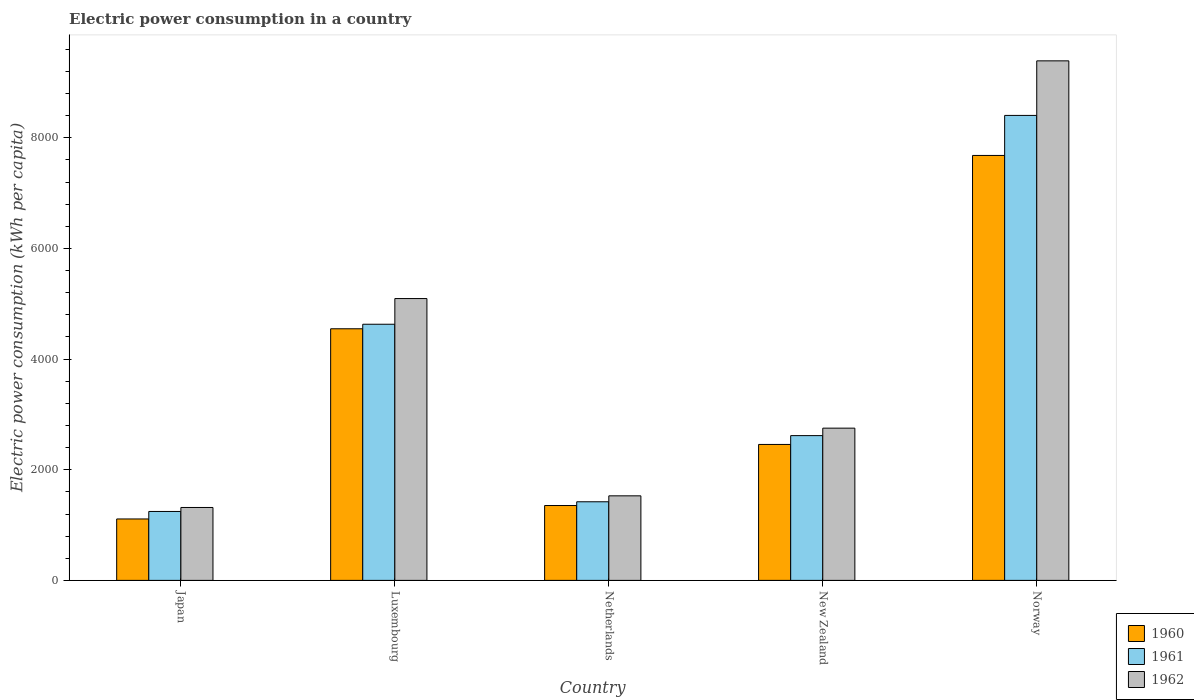How many different coloured bars are there?
Provide a short and direct response. 3. How many groups of bars are there?
Your answer should be compact. 5. Are the number of bars on each tick of the X-axis equal?
Make the answer very short. Yes. What is the label of the 1st group of bars from the left?
Keep it short and to the point. Japan. What is the electric power consumption in in 1961 in Japan?
Make the answer very short. 1246.01. Across all countries, what is the maximum electric power consumption in in 1962?
Keep it short and to the point. 9390.98. Across all countries, what is the minimum electric power consumption in in 1960?
Provide a succinct answer. 1110.26. In which country was the electric power consumption in in 1962 maximum?
Your response must be concise. Norway. What is the total electric power consumption in in 1960 in the graph?
Your answer should be compact. 1.72e+04. What is the difference between the electric power consumption in in 1961 in Japan and that in Luxembourg?
Make the answer very short. -3384.01. What is the difference between the electric power consumption in in 1961 in New Zealand and the electric power consumption in in 1962 in Norway?
Ensure brevity in your answer.  -6774.12. What is the average electric power consumption in in 1960 per country?
Give a very brief answer. 3430.04. What is the difference between the electric power consumption in of/in 1961 and electric power consumption in of/in 1962 in Luxembourg?
Keep it short and to the point. -464.29. In how many countries, is the electric power consumption in in 1962 greater than 800 kWh per capita?
Keep it short and to the point. 5. What is the ratio of the electric power consumption in in 1962 in Japan to that in Netherlands?
Your answer should be very brief. 0.86. Is the electric power consumption in in 1961 in Netherlands less than that in Norway?
Offer a very short reply. Yes. Is the difference between the electric power consumption in in 1961 in Luxembourg and Netherlands greater than the difference between the electric power consumption in in 1962 in Luxembourg and Netherlands?
Your response must be concise. No. What is the difference between the highest and the second highest electric power consumption in in 1962?
Ensure brevity in your answer.  -4296.67. What is the difference between the highest and the lowest electric power consumption in in 1962?
Give a very brief answer. 8073.05. Is the sum of the electric power consumption in in 1962 in Netherlands and Norway greater than the maximum electric power consumption in in 1960 across all countries?
Provide a short and direct response. Yes. What does the 1st bar from the left in Luxembourg represents?
Your response must be concise. 1960. What does the 2nd bar from the right in Netherlands represents?
Your answer should be compact. 1961. Is it the case that in every country, the sum of the electric power consumption in in 1962 and electric power consumption in in 1961 is greater than the electric power consumption in in 1960?
Your response must be concise. Yes. Does the graph contain any zero values?
Your response must be concise. No. Does the graph contain grids?
Offer a terse response. No. Where does the legend appear in the graph?
Your answer should be compact. Bottom right. How many legend labels are there?
Offer a terse response. 3. What is the title of the graph?
Your response must be concise. Electric power consumption in a country. Does "1991" appear as one of the legend labels in the graph?
Offer a terse response. No. What is the label or title of the Y-axis?
Provide a succinct answer. Electric power consumption (kWh per capita). What is the Electric power consumption (kWh per capita) of 1960 in Japan?
Your answer should be very brief. 1110.26. What is the Electric power consumption (kWh per capita) of 1961 in Japan?
Give a very brief answer. 1246.01. What is the Electric power consumption (kWh per capita) of 1962 in Japan?
Your answer should be compact. 1317.93. What is the Electric power consumption (kWh per capita) of 1960 in Luxembourg?
Provide a short and direct response. 4548.21. What is the Electric power consumption (kWh per capita) of 1961 in Luxembourg?
Offer a terse response. 4630.02. What is the Electric power consumption (kWh per capita) in 1962 in Luxembourg?
Offer a terse response. 5094.31. What is the Electric power consumption (kWh per capita) of 1960 in Netherlands?
Ensure brevity in your answer.  1353.4. What is the Electric power consumption (kWh per capita) in 1961 in Netherlands?
Provide a short and direct response. 1421.03. What is the Electric power consumption (kWh per capita) in 1962 in Netherlands?
Provide a short and direct response. 1528.5. What is the Electric power consumption (kWh per capita) of 1960 in New Zealand?
Your response must be concise. 2457.21. What is the Electric power consumption (kWh per capita) in 1961 in New Zealand?
Offer a very short reply. 2616.85. What is the Electric power consumption (kWh per capita) in 1962 in New Zealand?
Keep it short and to the point. 2751.81. What is the Electric power consumption (kWh per capita) in 1960 in Norway?
Keep it short and to the point. 7681.14. What is the Electric power consumption (kWh per capita) in 1961 in Norway?
Your response must be concise. 8404.62. What is the Electric power consumption (kWh per capita) in 1962 in Norway?
Provide a short and direct response. 9390.98. Across all countries, what is the maximum Electric power consumption (kWh per capita) in 1960?
Give a very brief answer. 7681.14. Across all countries, what is the maximum Electric power consumption (kWh per capita) in 1961?
Keep it short and to the point. 8404.62. Across all countries, what is the maximum Electric power consumption (kWh per capita) in 1962?
Provide a short and direct response. 9390.98. Across all countries, what is the minimum Electric power consumption (kWh per capita) in 1960?
Provide a succinct answer. 1110.26. Across all countries, what is the minimum Electric power consumption (kWh per capita) in 1961?
Give a very brief answer. 1246.01. Across all countries, what is the minimum Electric power consumption (kWh per capita) of 1962?
Offer a very short reply. 1317.93. What is the total Electric power consumption (kWh per capita) of 1960 in the graph?
Ensure brevity in your answer.  1.72e+04. What is the total Electric power consumption (kWh per capita) of 1961 in the graph?
Ensure brevity in your answer.  1.83e+04. What is the total Electric power consumption (kWh per capita) of 1962 in the graph?
Provide a succinct answer. 2.01e+04. What is the difference between the Electric power consumption (kWh per capita) of 1960 in Japan and that in Luxembourg?
Keep it short and to the point. -3437.94. What is the difference between the Electric power consumption (kWh per capita) in 1961 in Japan and that in Luxembourg?
Provide a short and direct response. -3384.01. What is the difference between the Electric power consumption (kWh per capita) of 1962 in Japan and that in Luxembourg?
Ensure brevity in your answer.  -3776.38. What is the difference between the Electric power consumption (kWh per capita) of 1960 in Japan and that in Netherlands?
Give a very brief answer. -243.14. What is the difference between the Electric power consumption (kWh per capita) in 1961 in Japan and that in Netherlands?
Your answer should be very brief. -175.02. What is the difference between the Electric power consumption (kWh per capita) of 1962 in Japan and that in Netherlands?
Make the answer very short. -210.57. What is the difference between the Electric power consumption (kWh per capita) of 1960 in Japan and that in New Zealand?
Your answer should be compact. -1346.94. What is the difference between the Electric power consumption (kWh per capita) in 1961 in Japan and that in New Zealand?
Keep it short and to the point. -1370.84. What is the difference between the Electric power consumption (kWh per capita) of 1962 in Japan and that in New Zealand?
Your response must be concise. -1433.88. What is the difference between the Electric power consumption (kWh per capita) in 1960 in Japan and that in Norway?
Provide a succinct answer. -6570.88. What is the difference between the Electric power consumption (kWh per capita) in 1961 in Japan and that in Norway?
Your response must be concise. -7158.61. What is the difference between the Electric power consumption (kWh per capita) in 1962 in Japan and that in Norway?
Your answer should be very brief. -8073.05. What is the difference between the Electric power consumption (kWh per capita) of 1960 in Luxembourg and that in Netherlands?
Provide a succinct answer. 3194.81. What is the difference between the Electric power consumption (kWh per capita) of 1961 in Luxembourg and that in Netherlands?
Provide a short and direct response. 3208.99. What is the difference between the Electric power consumption (kWh per capita) of 1962 in Luxembourg and that in Netherlands?
Offer a very short reply. 3565.81. What is the difference between the Electric power consumption (kWh per capita) of 1960 in Luxembourg and that in New Zealand?
Offer a terse response. 2091. What is the difference between the Electric power consumption (kWh per capita) of 1961 in Luxembourg and that in New Zealand?
Keep it short and to the point. 2013.17. What is the difference between the Electric power consumption (kWh per capita) in 1962 in Luxembourg and that in New Zealand?
Provide a short and direct response. 2342.5. What is the difference between the Electric power consumption (kWh per capita) in 1960 in Luxembourg and that in Norway?
Offer a terse response. -3132.94. What is the difference between the Electric power consumption (kWh per capita) in 1961 in Luxembourg and that in Norway?
Ensure brevity in your answer.  -3774.6. What is the difference between the Electric power consumption (kWh per capita) of 1962 in Luxembourg and that in Norway?
Make the answer very short. -4296.67. What is the difference between the Electric power consumption (kWh per capita) of 1960 in Netherlands and that in New Zealand?
Your response must be concise. -1103.81. What is the difference between the Electric power consumption (kWh per capita) in 1961 in Netherlands and that in New Zealand?
Offer a terse response. -1195.82. What is the difference between the Electric power consumption (kWh per capita) of 1962 in Netherlands and that in New Zealand?
Ensure brevity in your answer.  -1223.31. What is the difference between the Electric power consumption (kWh per capita) of 1960 in Netherlands and that in Norway?
Provide a succinct answer. -6327.74. What is the difference between the Electric power consumption (kWh per capita) of 1961 in Netherlands and that in Norway?
Offer a terse response. -6983.59. What is the difference between the Electric power consumption (kWh per capita) of 1962 in Netherlands and that in Norway?
Offer a terse response. -7862.48. What is the difference between the Electric power consumption (kWh per capita) of 1960 in New Zealand and that in Norway?
Your answer should be compact. -5223.94. What is the difference between the Electric power consumption (kWh per capita) of 1961 in New Zealand and that in Norway?
Keep it short and to the point. -5787.77. What is the difference between the Electric power consumption (kWh per capita) in 1962 in New Zealand and that in Norway?
Your answer should be compact. -6639.17. What is the difference between the Electric power consumption (kWh per capita) in 1960 in Japan and the Electric power consumption (kWh per capita) in 1961 in Luxembourg?
Your answer should be compact. -3519.76. What is the difference between the Electric power consumption (kWh per capita) in 1960 in Japan and the Electric power consumption (kWh per capita) in 1962 in Luxembourg?
Offer a terse response. -3984.05. What is the difference between the Electric power consumption (kWh per capita) of 1961 in Japan and the Electric power consumption (kWh per capita) of 1962 in Luxembourg?
Keep it short and to the point. -3848.3. What is the difference between the Electric power consumption (kWh per capita) of 1960 in Japan and the Electric power consumption (kWh per capita) of 1961 in Netherlands?
Provide a succinct answer. -310.77. What is the difference between the Electric power consumption (kWh per capita) in 1960 in Japan and the Electric power consumption (kWh per capita) in 1962 in Netherlands?
Your response must be concise. -418.24. What is the difference between the Electric power consumption (kWh per capita) in 1961 in Japan and the Electric power consumption (kWh per capita) in 1962 in Netherlands?
Your answer should be very brief. -282.49. What is the difference between the Electric power consumption (kWh per capita) of 1960 in Japan and the Electric power consumption (kWh per capita) of 1961 in New Zealand?
Your response must be concise. -1506.59. What is the difference between the Electric power consumption (kWh per capita) of 1960 in Japan and the Electric power consumption (kWh per capita) of 1962 in New Zealand?
Ensure brevity in your answer.  -1641.55. What is the difference between the Electric power consumption (kWh per capita) of 1961 in Japan and the Electric power consumption (kWh per capita) of 1962 in New Zealand?
Give a very brief answer. -1505.8. What is the difference between the Electric power consumption (kWh per capita) in 1960 in Japan and the Electric power consumption (kWh per capita) in 1961 in Norway?
Give a very brief answer. -7294.36. What is the difference between the Electric power consumption (kWh per capita) in 1960 in Japan and the Electric power consumption (kWh per capita) in 1962 in Norway?
Your response must be concise. -8280.71. What is the difference between the Electric power consumption (kWh per capita) in 1961 in Japan and the Electric power consumption (kWh per capita) in 1962 in Norway?
Make the answer very short. -8144.97. What is the difference between the Electric power consumption (kWh per capita) in 1960 in Luxembourg and the Electric power consumption (kWh per capita) in 1961 in Netherlands?
Offer a terse response. 3127.17. What is the difference between the Electric power consumption (kWh per capita) of 1960 in Luxembourg and the Electric power consumption (kWh per capita) of 1962 in Netherlands?
Your response must be concise. 3019.7. What is the difference between the Electric power consumption (kWh per capita) in 1961 in Luxembourg and the Electric power consumption (kWh per capita) in 1962 in Netherlands?
Your response must be concise. 3101.52. What is the difference between the Electric power consumption (kWh per capita) in 1960 in Luxembourg and the Electric power consumption (kWh per capita) in 1961 in New Zealand?
Keep it short and to the point. 1931.35. What is the difference between the Electric power consumption (kWh per capita) in 1960 in Luxembourg and the Electric power consumption (kWh per capita) in 1962 in New Zealand?
Your response must be concise. 1796.39. What is the difference between the Electric power consumption (kWh per capita) of 1961 in Luxembourg and the Electric power consumption (kWh per capita) of 1962 in New Zealand?
Your answer should be compact. 1878.21. What is the difference between the Electric power consumption (kWh per capita) in 1960 in Luxembourg and the Electric power consumption (kWh per capita) in 1961 in Norway?
Provide a succinct answer. -3856.42. What is the difference between the Electric power consumption (kWh per capita) of 1960 in Luxembourg and the Electric power consumption (kWh per capita) of 1962 in Norway?
Give a very brief answer. -4842.77. What is the difference between the Electric power consumption (kWh per capita) in 1961 in Luxembourg and the Electric power consumption (kWh per capita) in 1962 in Norway?
Offer a terse response. -4760.95. What is the difference between the Electric power consumption (kWh per capita) in 1960 in Netherlands and the Electric power consumption (kWh per capita) in 1961 in New Zealand?
Offer a terse response. -1263.45. What is the difference between the Electric power consumption (kWh per capita) of 1960 in Netherlands and the Electric power consumption (kWh per capita) of 1962 in New Zealand?
Offer a very short reply. -1398.41. What is the difference between the Electric power consumption (kWh per capita) in 1961 in Netherlands and the Electric power consumption (kWh per capita) in 1962 in New Zealand?
Keep it short and to the point. -1330.78. What is the difference between the Electric power consumption (kWh per capita) in 1960 in Netherlands and the Electric power consumption (kWh per capita) in 1961 in Norway?
Keep it short and to the point. -7051.22. What is the difference between the Electric power consumption (kWh per capita) of 1960 in Netherlands and the Electric power consumption (kWh per capita) of 1962 in Norway?
Give a very brief answer. -8037.58. What is the difference between the Electric power consumption (kWh per capita) in 1961 in Netherlands and the Electric power consumption (kWh per capita) in 1962 in Norway?
Provide a succinct answer. -7969.94. What is the difference between the Electric power consumption (kWh per capita) of 1960 in New Zealand and the Electric power consumption (kWh per capita) of 1961 in Norway?
Offer a terse response. -5947.42. What is the difference between the Electric power consumption (kWh per capita) in 1960 in New Zealand and the Electric power consumption (kWh per capita) in 1962 in Norway?
Ensure brevity in your answer.  -6933.77. What is the difference between the Electric power consumption (kWh per capita) in 1961 in New Zealand and the Electric power consumption (kWh per capita) in 1962 in Norway?
Give a very brief answer. -6774.12. What is the average Electric power consumption (kWh per capita) in 1960 per country?
Give a very brief answer. 3430.04. What is the average Electric power consumption (kWh per capita) of 1961 per country?
Provide a short and direct response. 3663.71. What is the average Electric power consumption (kWh per capita) in 1962 per country?
Offer a very short reply. 4016.71. What is the difference between the Electric power consumption (kWh per capita) of 1960 and Electric power consumption (kWh per capita) of 1961 in Japan?
Offer a terse response. -135.75. What is the difference between the Electric power consumption (kWh per capita) in 1960 and Electric power consumption (kWh per capita) in 1962 in Japan?
Offer a terse response. -207.67. What is the difference between the Electric power consumption (kWh per capita) in 1961 and Electric power consumption (kWh per capita) in 1962 in Japan?
Give a very brief answer. -71.92. What is the difference between the Electric power consumption (kWh per capita) in 1960 and Electric power consumption (kWh per capita) in 1961 in Luxembourg?
Give a very brief answer. -81.82. What is the difference between the Electric power consumption (kWh per capita) of 1960 and Electric power consumption (kWh per capita) of 1962 in Luxembourg?
Provide a succinct answer. -546.11. What is the difference between the Electric power consumption (kWh per capita) in 1961 and Electric power consumption (kWh per capita) in 1962 in Luxembourg?
Keep it short and to the point. -464.29. What is the difference between the Electric power consumption (kWh per capita) of 1960 and Electric power consumption (kWh per capita) of 1961 in Netherlands?
Give a very brief answer. -67.63. What is the difference between the Electric power consumption (kWh per capita) of 1960 and Electric power consumption (kWh per capita) of 1962 in Netherlands?
Provide a short and direct response. -175.1. What is the difference between the Electric power consumption (kWh per capita) in 1961 and Electric power consumption (kWh per capita) in 1962 in Netherlands?
Keep it short and to the point. -107.47. What is the difference between the Electric power consumption (kWh per capita) in 1960 and Electric power consumption (kWh per capita) in 1961 in New Zealand?
Keep it short and to the point. -159.65. What is the difference between the Electric power consumption (kWh per capita) in 1960 and Electric power consumption (kWh per capita) in 1962 in New Zealand?
Make the answer very short. -294.61. What is the difference between the Electric power consumption (kWh per capita) of 1961 and Electric power consumption (kWh per capita) of 1962 in New Zealand?
Keep it short and to the point. -134.96. What is the difference between the Electric power consumption (kWh per capita) in 1960 and Electric power consumption (kWh per capita) in 1961 in Norway?
Make the answer very short. -723.48. What is the difference between the Electric power consumption (kWh per capita) of 1960 and Electric power consumption (kWh per capita) of 1962 in Norway?
Ensure brevity in your answer.  -1709.84. What is the difference between the Electric power consumption (kWh per capita) of 1961 and Electric power consumption (kWh per capita) of 1962 in Norway?
Provide a succinct answer. -986.36. What is the ratio of the Electric power consumption (kWh per capita) in 1960 in Japan to that in Luxembourg?
Ensure brevity in your answer.  0.24. What is the ratio of the Electric power consumption (kWh per capita) of 1961 in Japan to that in Luxembourg?
Provide a short and direct response. 0.27. What is the ratio of the Electric power consumption (kWh per capita) in 1962 in Japan to that in Luxembourg?
Offer a terse response. 0.26. What is the ratio of the Electric power consumption (kWh per capita) of 1960 in Japan to that in Netherlands?
Make the answer very short. 0.82. What is the ratio of the Electric power consumption (kWh per capita) of 1961 in Japan to that in Netherlands?
Give a very brief answer. 0.88. What is the ratio of the Electric power consumption (kWh per capita) in 1962 in Japan to that in Netherlands?
Your response must be concise. 0.86. What is the ratio of the Electric power consumption (kWh per capita) in 1960 in Japan to that in New Zealand?
Provide a succinct answer. 0.45. What is the ratio of the Electric power consumption (kWh per capita) in 1961 in Japan to that in New Zealand?
Your response must be concise. 0.48. What is the ratio of the Electric power consumption (kWh per capita) of 1962 in Japan to that in New Zealand?
Provide a short and direct response. 0.48. What is the ratio of the Electric power consumption (kWh per capita) in 1960 in Japan to that in Norway?
Make the answer very short. 0.14. What is the ratio of the Electric power consumption (kWh per capita) of 1961 in Japan to that in Norway?
Ensure brevity in your answer.  0.15. What is the ratio of the Electric power consumption (kWh per capita) of 1962 in Japan to that in Norway?
Ensure brevity in your answer.  0.14. What is the ratio of the Electric power consumption (kWh per capita) in 1960 in Luxembourg to that in Netherlands?
Provide a succinct answer. 3.36. What is the ratio of the Electric power consumption (kWh per capita) in 1961 in Luxembourg to that in Netherlands?
Keep it short and to the point. 3.26. What is the ratio of the Electric power consumption (kWh per capita) in 1962 in Luxembourg to that in Netherlands?
Ensure brevity in your answer.  3.33. What is the ratio of the Electric power consumption (kWh per capita) in 1960 in Luxembourg to that in New Zealand?
Give a very brief answer. 1.85. What is the ratio of the Electric power consumption (kWh per capita) of 1961 in Luxembourg to that in New Zealand?
Ensure brevity in your answer.  1.77. What is the ratio of the Electric power consumption (kWh per capita) of 1962 in Luxembourg to that in New Zealand?
Offer a terse response. 1.85. What is the ratio of the Electric power consumption (kWh per capita) of 1960 in Luxembourg to that in Norway?
Provide a short and direct response. 0.59. What is the ratio of the Electric power consumption (kWh per capita) in 1961 in Luxembourg to that in Norway?
Give a very brief answer. 0.55. What is the ratio of the Electric power consumption (kWh per capita) in 1962 in Luxembourg to that in Norway?
Ensure brevity in your answer.  0.54. What is the ratio of the Electric power consumption (kWh per capita) in 1960 in Netherlands to that in New Zealand?
Provide a succinct answer. 0.55. What is the ratio of the Electric power consumption (kWh per capita) in 1961 in Netherlands to that in New Zealand?
Your response must be concise. 0.54. What is the ratio of the Electric power consumption (kWh per capita) of 1962 in Netherlands to that in New Zealand?
Offer a terse response. 0.56. What is the ratio of the Electric power consumption (kWh per capita) of 1960 in Netherlands to that in Norway?
Your answer should be compact. 0.18. What is the ratio of the Electric power consumption (kWh per capita) of 1961 in Netherlands to that in Norway?
Keep it short and to the point. 0.17. What is the ratio of the Electric power consumption (kWh per capita) in 1962 in Netherlands to that in Norway?
Offer a terse response. 0.16. What is the ratio of the Electric power consumption (kWh per capita) of 1960 in New Zealand to that in Norway?
Give a very brief answer. 0.32. What is the ratio of the Electric power consumption (kWh per capita) in 1961 in New Zealand to that in Norway?
Provide a short and direct response. 0.31. What is the ratio of the Electric power consumption (kWh per capita) in 1962 in New Zealand to that in Norway?
Your response must be concise. 0.29. What is the difference between the highest and the second highest Electric power consumption (kWh per capita) in 1960?
Your answer should be compact. 3132.94. What is the difference between the highest and the second highest Electric power consumption (kWh per capita) of 1961?
Your response must be concise. 3774.6. What is the difference between the highest and the second highest Electric power consumption (kWh per capita) in 1962?
Keep it short and to the point. 4296.67. What is the difference between the highest and the lowest Electric power consumption (kWh per capita) of 1960?
Make the answer very short. 6570.88. What is the difference between the highest and the lowest Electric power consumption (kWh per capita) in 1961?
Provide a short and direct response. 7158.61. What is the difference between the highest and the lowest Electric power consumption (kWh per capita) of 1962?
Provide a short and direct response. 8073.05. 